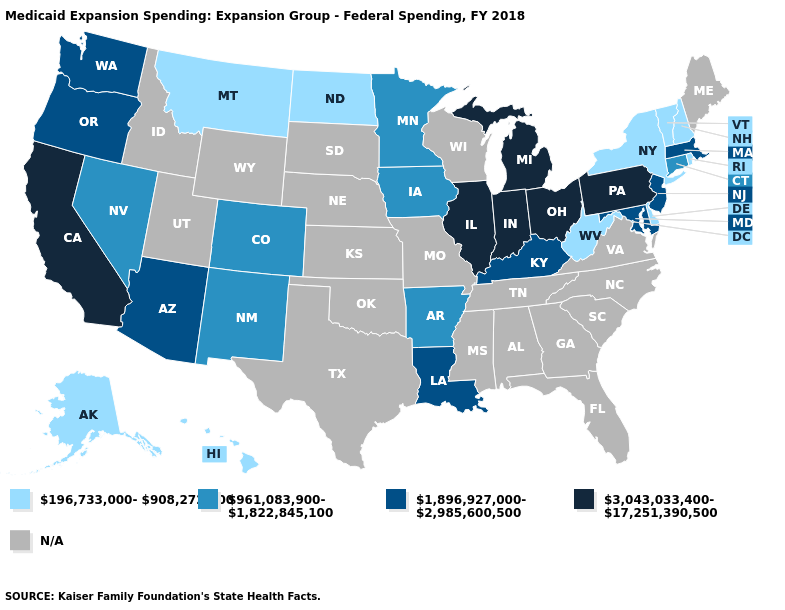What is the value of Colorado?
Be succinct. 961,083,900-1,822,845,100. Which states hav the highest value in the West?
Write a very short answer. California. Does the map have missing data?
Answer briefly. Yes. Name the states that have a value in the range 196,733,000-908,272,700?
Quick response, please. Alaska, Delaware, Hawaii, Montana, New Hampshire, New York, North Dakota, Rhode Island, Vermont, West Virginia. What is the value of New Jersey?
Give a very brief answer. 1,896,927,000-2,985,600,500. Which states have the lowest value in the South?
Answer briefly. Delaware, West Virginia. Which states have the lowest value in the USA?
Answer briefly. Alaska, Delaware, Hawaii, Montana, New Hampshire, New York, North Dakota, Rhode Island, Vermont, West Virginia. Does the map have missing data?
Answer briefly. Yes. What is the value of Indiana?
Concise answer only. 3,043,033,400-17,251,390,500. Name the states that have a value in the range 196,733,000-908,272,700?
Give a very brief answer. Alaska, Delaware, Hawaii, Montana, New Hampshire, New York, North Dakota, Rhode Island, Vermont, West Virginia. Does the first symbol in the legend represent the smallest category?
Be succinct. Yes. Name the states that have a value in the range 3,043,033,400-17,251,390,500?
Concise answer only. California, Illinois, Indiana, Michigan, Ohio, Pennsylvania. Name the states that have a value in the range N/A?
Quick response, please. Alabama, Florida, Georgia, Idaho, Kansas, Maine, Mississippi, Missouri, Nebraska, North Carolina, Oklahoma, South Carolina, South Dakota, Tennessee, Texas, Utah, Virginia, Wisconsin, Wyoming. 